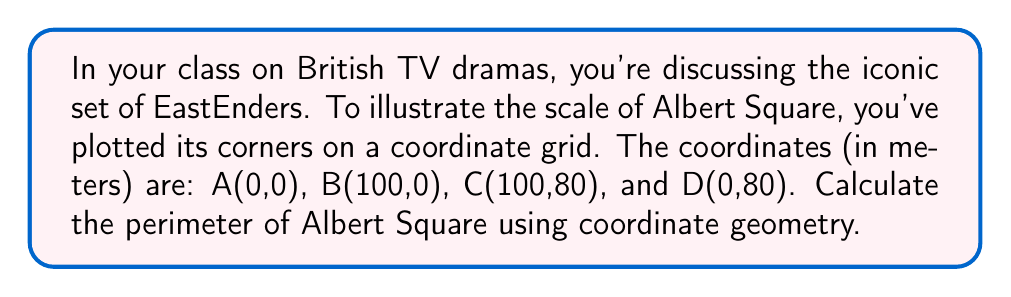Teach me how to tackle this problem. To find the perimeter of Albert Square, we need to calculate the distance between each pair of consecutive points and sum them up. We'll use the distance formula:

$$d = \sqrt{(x_2-x_1)^2 + (y_2-y_1)^2}$$

Step 1: Calculate AB
$AB = \sqrt{(100-0)^2 + (0-0)^2} = 100$ m

Step 2: Calculate BC
$BC = \sqrt{(100-100)^2 + (80-0)^2} = 80$ m

Step 3: Calculate CD
$CD = \sqrt{(0-100)^2 + (80-80)^2} = 100$ m

Step 4: Calculate DA
$DA = \sqrt{(0-0)^2 + (0-80)^2} = 80$ m

Step 5: Sum all sides
Perimeter = AB + BC + CD + DA = 100 + 80 + 100 + 80 = 360 m

[asy]
unitsize(1mm);
draw((0,0)--(100,0)--(100,80)--(0,80)--cycle);
label("A(0,0)", (0,0), SW);
label("B(100,0)", (100,0), SE);
label("C(100,80)", (100,80), NE);
label("D(0,80)", (0,80), NW);
label("100 m", (50,0), S);
label("80 m", (100,40), E);
label("100 m", (50,80), N);
label("80 m", (0,40), W);
[/asy]
Answer: 360 m 